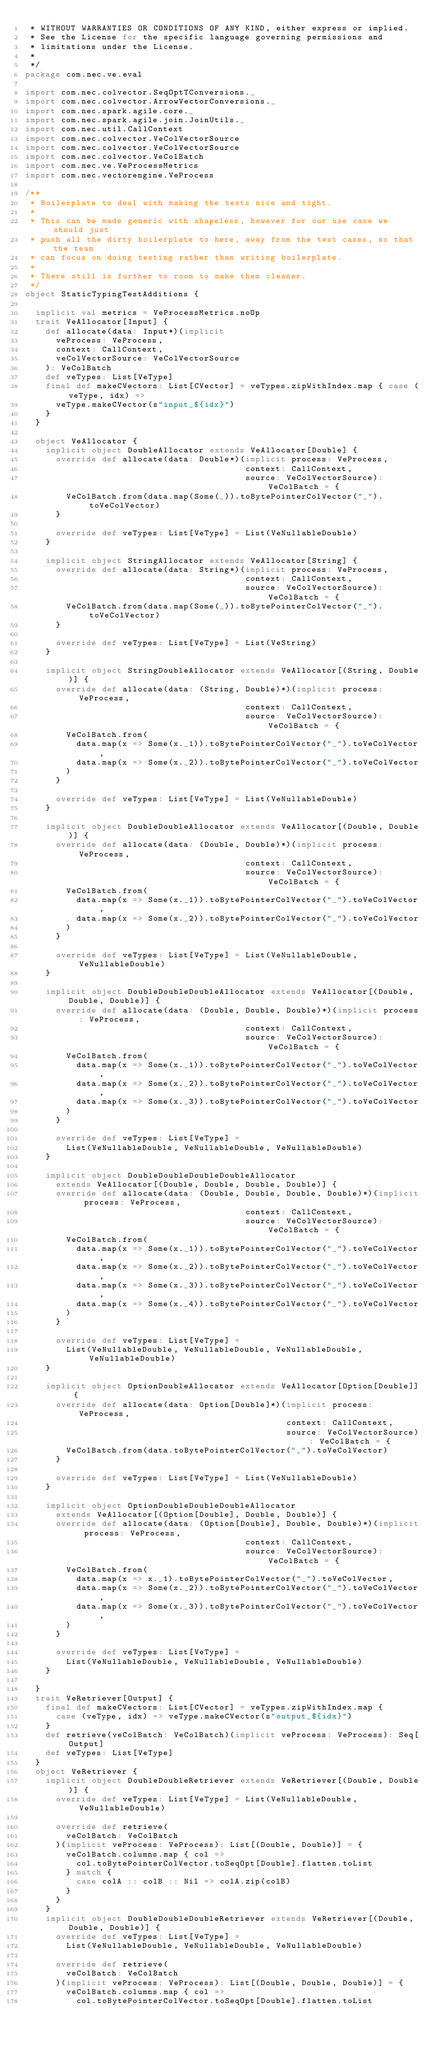Convert code to text. <code><loc_0><loc_0><loc_500><loc_500><_Scala_> * WITHOUT WARRANTIES OR CONDITIONS OF ANY KIND, either express or implied.
 * See the License for the specific language governing permissions and
 * limitations under the License.
 *
 */
package com.nec.ve.eval

import com.nec.colvector.SeqOptTConversions._
import com.nec.colvector.ArrowVectorConversions._
import com.nec.spark.agile.core._
import com.nec.spark.agile.join.JoinUtils._
import com.nec.util.CallContext
import com.nec.colvector.VeColVectorSource
import com.nec.colvector.VeColVectorSource
import com.nec.colvector.VeColBatch
import com.nec.ve.VeProcessMetrics
import com.nec.vectorengine.VeProcess

/**
 * Boilerplate to deal with making the tests nice and tight.
 *
 * This can be made generic with shapeless, however for our use case we should just
 * push all the dirty boilerplate to here, away from the test cases, so that the team
 * can focus on doing testing rather than writing boilerplate.
 *
 * There still is further to room to make them cleaner.
 */
object StaticTypingTestAdditions {

  implicit val metrics = VeProcessMetrics.noOp
  trait VeAllocator[Input] {
    def allocate(data: Input*)(implicit
      veProcess: VeProcess,
      context: CallContext,
      veColVectorSource: VeColVectorSource
    ): VeColBatch
    def veTypes: List[VeType]
    final def makeCVectors: List[CVector] = veTypes.zipWithIndex.map { case (veType, idx) =>
      veType.makeCVector(s"input_${idx}")
    }
  }

  object VeAllocator {
    implicit object DoubleAllocator extends VeAllocator[Double] {
      override def allocate(data: Double*)(implicit process: VeProcess,
                                           context: CallContext,
                                           source: VeColVectorSource): VeColBatch = {
        VeColBatch.from(data.map(Some(_)).toBytePointerColVector("_").toVeColVector)
      }

      override def veTypes: List[VeType] = List(VeNullableDouble)
    }

    implicit object StringAllocator extends VeAllocator[String] {
      override def allocate(data: String*)(implicit process: VeProcess,
                                           context: CallContext,
                                           source: VeColVectorSource): VeColBatch = {
        VeColBatch.from(data.map(Some(_)).toBytePointerColVector("_").toVeColVector)
      }

      override def veTypes: List[VeType] = List(VeString)
    }

    implicit object StringDoubleAllocator extends VeAllocator[(String, Double)] {
      override def allocate(data: (String, Double)*)(implicit process: VeProcess,
                                           context: CallContext,
                                           source: VeColVectorSource): VeColBatch = {
        VeColBatch.from(
          data.map(x => Some(x._1)).toBytePointerColVector("_").toVeColVector,
          data.map(x => Some(x._2)).toBytePointerColVector("_").toVeColVector
        )
      }

      override def veTypes: List[VeType] = List(VeNullableDouble)
    }

    implicit object DoubleDoubleAllocator extends VeAllocator[(Double, Double)] {
      override def allocate(data: (Double, Double)*)(implicit process: VeProcess,
                                           context: CallContext,
                                           source: VeColVectorSource): VeColBatch = {
        VeColBatch.from(
          data.map(x => Some(x._1)).toBytePointerColVector("_").toVeColVector,
          data.map(x => Some(x._2)).toBytePointerColVector("_").toVeColVector
        )
      }

      override def veTypes: List[VeType] = List(VeNullableDouble, VeNullableDouble)
    }

    implicit object DoubleDoubleDoubleAllocator extends VeAllocator[(Double, Double, Double)] {
      override def allocate(data: (Double, Double, Double)*)(implicit process: VeProcess,
                                           context: CallContext,
                                           source: VeColVectorSource): VeColBatch = {
        VeColBatch.from(
          data.map(x => Some(x._1)).toBytePointerColVector("_").toVeColVector,
          data.map(x => Some(x._2)).toBytePointerColVector("_").toVeColVector,
          data.map(x => Some(x._3)).toBytePointerColVector("_").toVeColVector
        )
      }

      override def veTypes: List[VeType] =
        List(VeNullableDouble, VeNullableDouble, VeNullableDouble)
    }

    implicit object DoubleDoubleDoubleDoubleAllocator
      extends VeAllocator[(Double, Double, Double, Double)] {
      override def allocate(data: (Double, Double, Double, Double)*)(implicit process: VeProcess,
                                           context: CallContext,
                                           source: VeColVectorSource): VeColBatch = {
        VeColBatch.from(
          data.map(x => Some(x._1)).toBytePointerColVector("_").toVeColVector,
          data.map(x => Some(x._2)).toBytePointerColVector("_").toVeColVector,
          data.map(x => Some(x._3)).toBytePointerColVector("_").toVeColVector,
          data.map(x => Some(x._4)).toBytePointerColVector("_").toVeColVector
        )
      }

      override def veTypes: List[VeType] =
        List(VeNullableDouble, VeNullableDouble, VeNullableDouble, VeNullableDouble)
    }

    implicit object OptionDoubleAllocator extends VeAllocator[Option[Double]] {
      override def allocate(data: Option[Double]*)(implicit process: VeProcess,
                                                   context: CallContext,
                                                   source: VeColVectorSource): VeColBatch = {
        VeColBatch.from(data.toBytePointerColVector("_").toVeColVector)
      }

      override def veTypes: List[VeType] = List(VeNullableDouble)
    }

    implicit object OptionDoubleDoubleDoubleAllocator
      extends VeAllocator[(Option[Double], Double, Double)] {
      override def allocate(data: (Option[Double], Double, Double)*)(implicit process: VeProcess,
                                           context: CallContext,
                                           source: VeColVectorSource): VeColBatch = {
        VeColBatch.from(
          data.map(x => x._1).toBytePointerColVector("_").toVeColVector,
          data.map(x => Some(x._2)).toBytePointerColVector("_").toVeColVector,
          data.map(x => Some(x._3)).toBytePointerColVector("_").toVeColVector,
        )
      }

      override def veTypes: List[VeType] =
        List(VeNullableDouble, VeNullableDouble, VeNullableDouble)
    }

  }
  trait VeRetriever[Output] {
    final def makeCVectors: List[CVector] = veTypes.zipWithIndex.map {
      case (veType, idx) => veType.makeCVector(s"output_${idx}")
    }
    def retrieve(veColBatch: VeColBatch)(implicit veProcess: VeProcess): Seq[Output]
    def veTypes: List[VeType]
  }
  object VeRetriever {
    implicit object DoubleDoubleRetriever extends VeRetriever[(Double, Double)] {
      override def veTypes: List[VeType] = List(VeNullableDouble, VeNullableDouble)

      override def retrieve(
        veColBatch: VeColBatch
      )(implicit veProcess: VeProcess): List[(Double, Double)] = {
        veColBatch.columns.map { col =>
          col.toBytePointerColVector.toSeqOpt[Double].flatten.toList
        } match {
          case colA :: colB :: Nil => colA.zip(colB)
        }
      }
    }
    implicit object DoubleDoubleDoubleRetriever extends VeRetriever[(Double, Double, Double)] {
      override def veTypes: List[VeType] =
        List(VeNullableDouble, VeNullableDouble, VeNullableDouble)

      override def retrieve(
        veColBatch: VeColBatch
      )(implicit veProcess: VeProcess): List[(Double, Double, Double)] = {
        veColBatch.columns.map { col =>
          col.toBytePointerColVector.toSeqOpt[Double].flatten.toList
</code> 